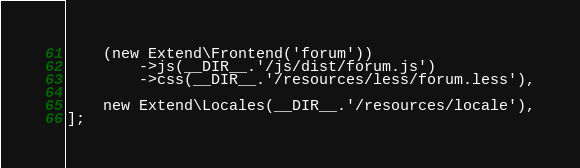<code> <loc_0><loc_0><loc_500><loc_500><_PHP_>    (new Extend\Frontend('forum'))
        ->js(__DIR__.'/js/dist/forum.js')
        ->css(__DIR__.'/resources/less/forum.less'),
    
    new Extend\Locales(__DIR__.'/resources/locale'),
];
</code> 